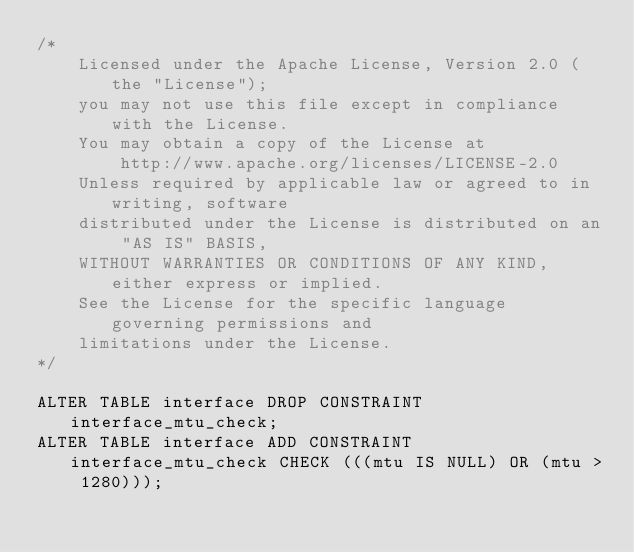Convert code to text. <code><loc_0><loc_0><loc_500><loc_500><_SQL_>/*
    Licensed under the Apache License, Version 2.0 (the "License");
    you may not use this file except in compliance with the License.
    You may obtain a copy of the License at
        http://www.apache.org/licenses/LICENSE-2.0
    Unless required by applicable law or agreed to in writing, software
    distributed under the License is distributed on an "AS IS" BASIS,
    WITHOUT WARRANTIES OR CONDITIONS OF ANY KIND, either express or implied.
    See the License for the specific language governing permissions and
    limitations under the License.
*/

ALTER TABLE interface DROP CONSTRAINT interface_mtu_check;
ALTER TABLE interface ADD CONSTRAINT interface_mtu_check CHECK (((mtu IS NULL) OR (mtu > 1280)));
</code> 